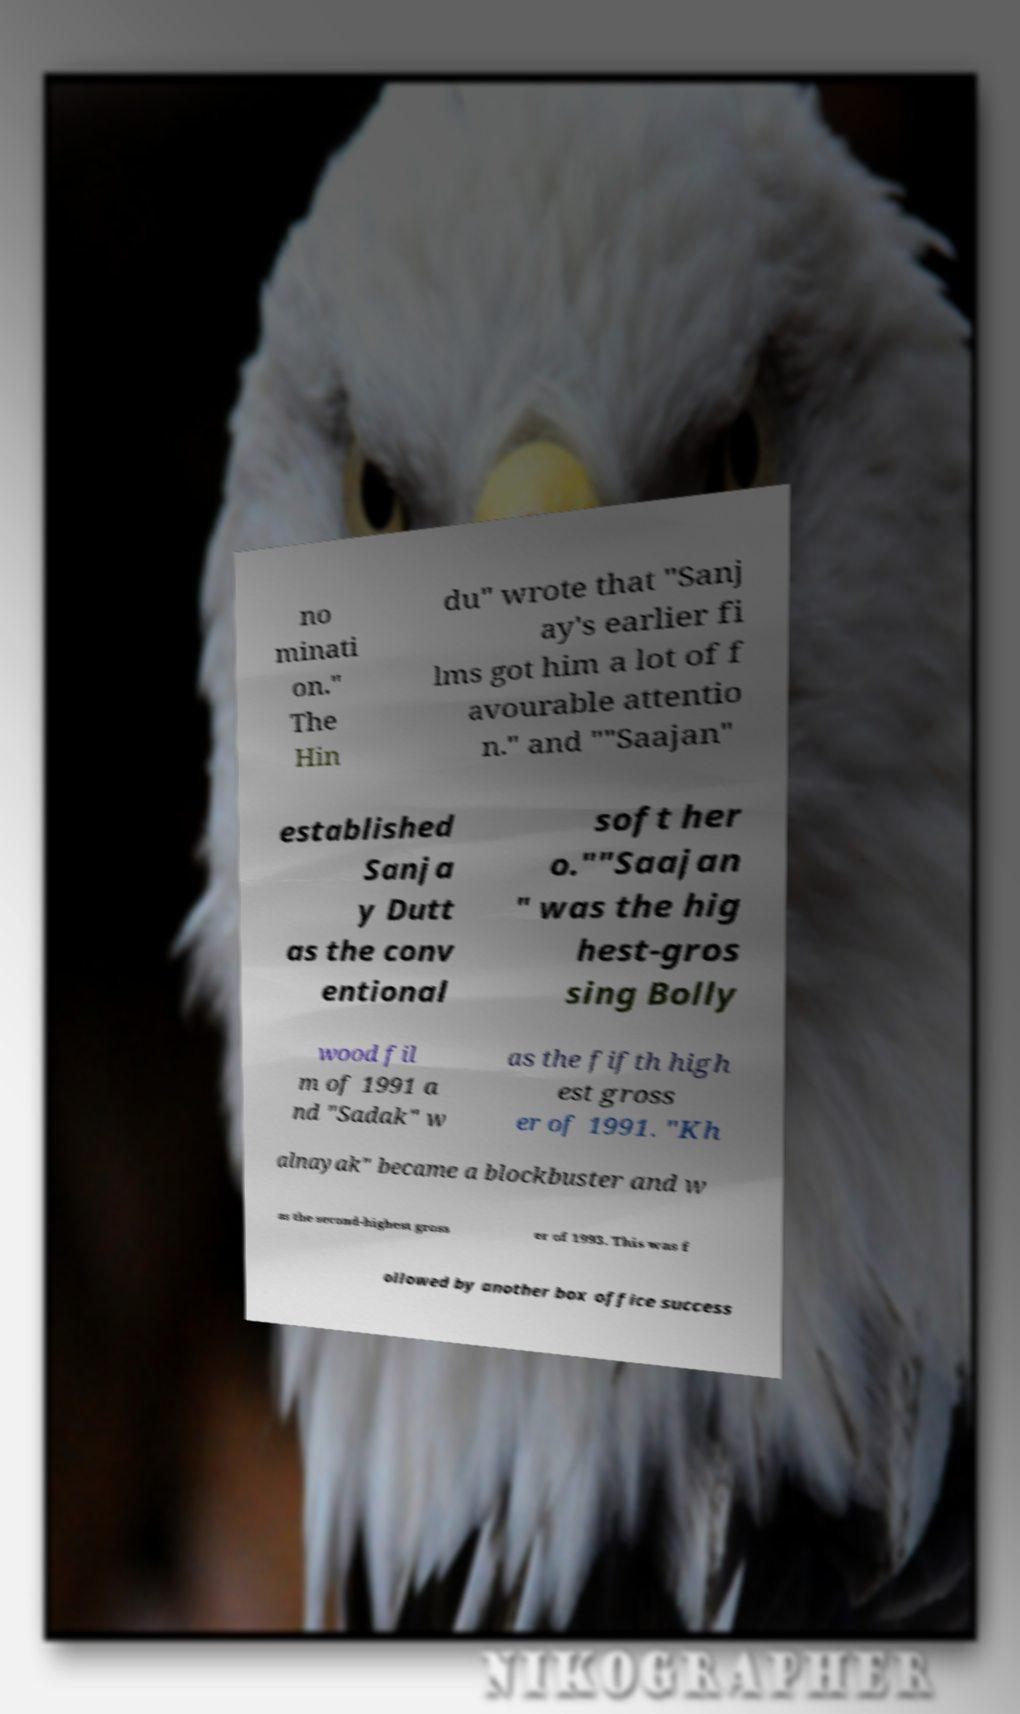There's text embedded in this image that I need extracted. Can you transcribe it verbatim? no minati on." The Hin du" wrote that "Sanj ay's earlier fi lms got him a lot of f avourable attentio n." and ""Saajan" established Sanja y Dutt as the conv entional soft her o.""Saajan " was the hig hest-gros sing Bolly wood fil m of 1991 a nd "Sadak" w as the fifth high est gross er of 1991. "Kh alnayak" became a blockbuster and w as the second-highest gross er of 1993. This was f ollowed by another box office success 